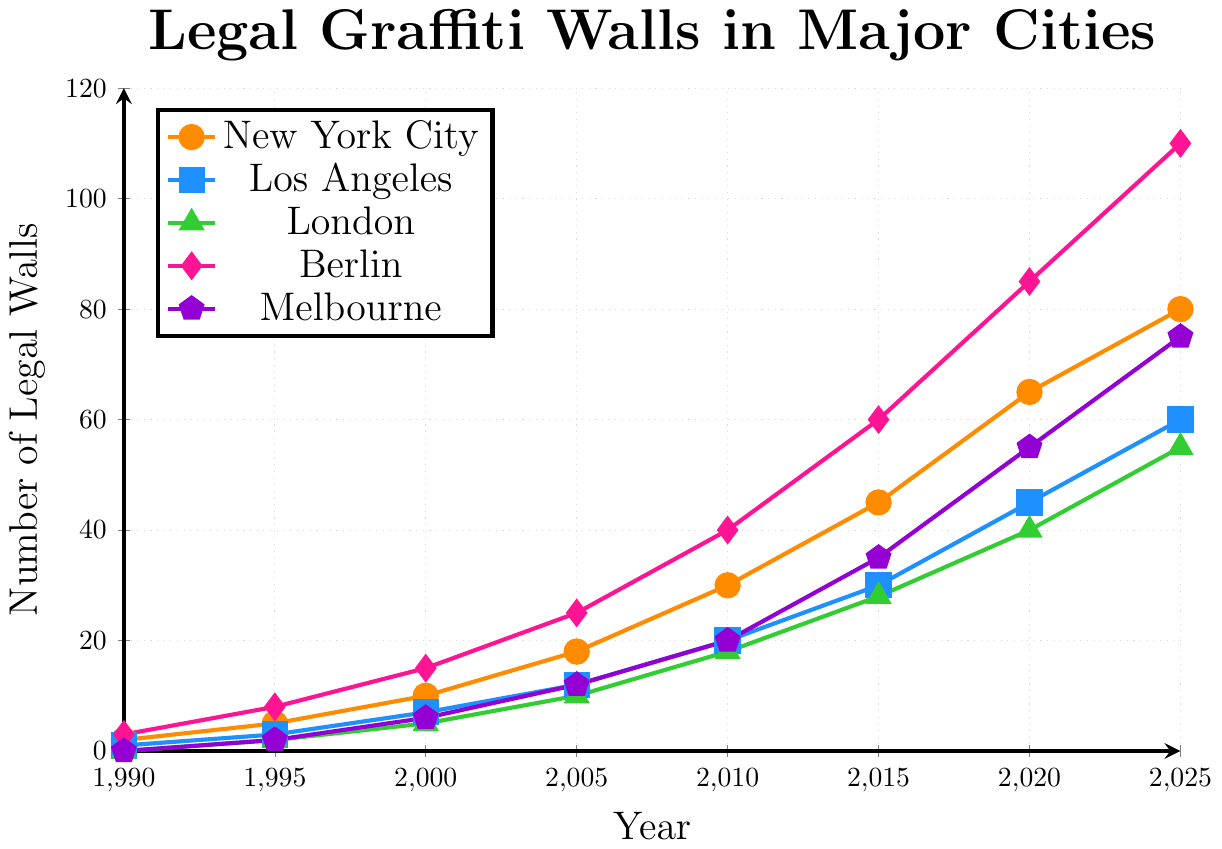What is the total number of legal graffiti walls in New York City and Los Angeles in the year 2005? First, find the number of legal graffiti walls in New York City and Los Angeles in 2005 from the figure. In 2005, New York City has 18 walls and Los Angeles has 12 walls. Add these two numbers together: 18 + 12 = 30.
Answer: 30 Which city showed the highest increase in the number of legal graffiti walls from 1990 to 2025? Compare the numbers of legal graffiti walls for each city between 1990 and 2025. New York City increased from 2 to 80 (78 increase), Los Angeles from 1 to 60 (59 increase), London from 0 to 55 (55 increase), Berlin from 3 to 110 (107 increase), and Melbourne from 0 to 75 (75 increase). Berlin shows the highest increase of 107 walls.
Answer: Berlin In which year did Melbourne have more legal graffiti walls than London? Examine the values for Melbourne and London across the years. In 2020, Melbourne has 55 walls, and London has 40 walls, so Melbourne has more. Hence, the year is 2020.
Answer: 2020 How many times more legal graffiti walls were there in Berlin in 2020 compared to London in 2005? First, find the number of walls in Berlin in 2020 (85) and in London in 2005 (10). Divide the Berlin value by the London value: 85 / 10 = 8.5 times.
Answer: 8.5 times What is the average number of legal graffiti walls in London over all the years provided? Sum the values for London: 0+2+5+10+18+28+40+55 = 158. There are 8 years. Divide the sum by the number of years: 158 / 8 = 19.75.
Answer: 19.75 Which city had the second highest number of legal graffiti walls in the year 2015? Look at the number of walls for each city in 2015. New York City (45), Los Angeles (30), London (28), Berlin (60), Melbourne (35). The second highest number of walls is 45 by New York City.
Answer: New York City How many more legal graffiti walls were in New York City than in Los Angeles in the year 2000? Find the values for New York City (10) and Los Angeles (7) in 2000 and subtract the Los Angeles value from the New York City value: 10 - 7 = 3.
Answer: 3 During which period did Berlin see the largest increase in the number of legal graffiti walls? To determine this, compare the increase in walls between consecutive periods for Berlin. The periods and corresponding increases are: 1990-1995: 5, 1995-2000: 7, 2000-2005: 10, 2005-2010: 15, 2010-2015: 20, 2015-2020: 25, 2020-2025: 25. The largest increase is 25, occurring in both 2015-2020 and 2020-2025.
Answer: 2015-2020 and 2020-2025 Which city had the least number of legal graffiti walls in 1995 and how many did it have? Compare the numbers provided for each city in 1995: New York City (5), Los Angeles (3), London (2), Berlin (8), Melbourne (2). Both London and Melbourne had the least number of walls, with 2 each.
Answer: London and Melbourne, 2 What is the difference between the number of legal graffiti walls in Berlin and Melbourne in 2025? Find the values for Berlin (110) and Melbourne (75) in 2025 and subtract the Melbourne value from the Berlin value: 110 - 75 = 35.
Answer: 35 